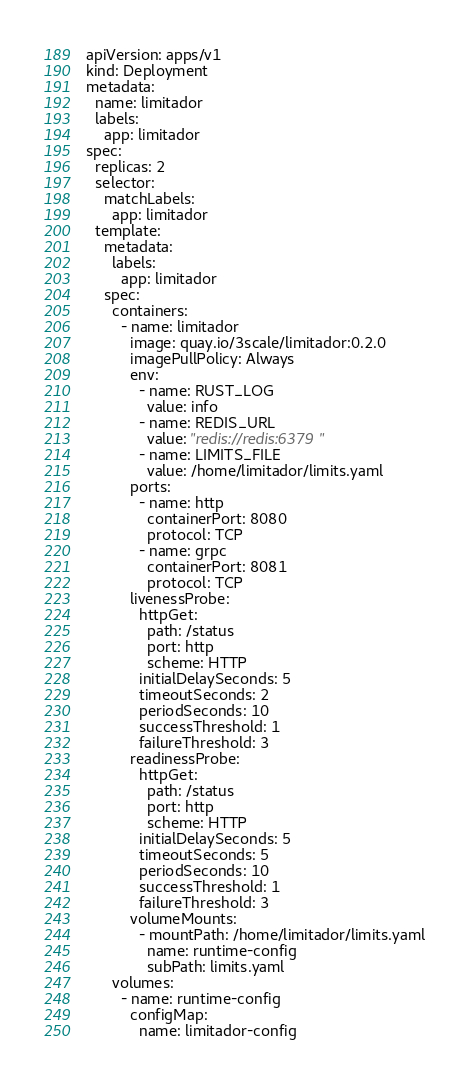<code> <loc_0><loc_0><loc_500><loc_500><_YAML_>apiVersion: apps/v1
kind: Deployment
metadata:
  name: limitador
  labels:
    app: limitador
spec:
  replicas: 2
  selector:
    matchLabels:
      app: limitador
  template:
    metadata:
      labels:
        app: limitador
    spec:
      containers:
        - name: limitador
          image: quay.io/3scale/limitador:0.2.0
          imagePullPolicy: Always
          env:
            - name: RUST_LOG
              value: info
            - name: REDIS_URL
              value: "redis://redis:6379"
            - name: LIMITS_FILE
              value: /home/limitador/limits.yaml
          ports:
            - name: http
              containerPort: 8080
              protocol: TCP
            - name: grpc
              containerPort: 8081
              protocol: TCP
          livenessProbe:
            httpGet:
              path: /status
              port: http
              scheme: HTTP
            initialDelaySeconds: 5
            timeoutSeconds: 2
            periodSeconds: 10
            successThreshold: 1
            failureThreshold: 3
          readinessProbe:
            httpGet:
              path: /status
              port: http
              scheme: HTTP
            initialDelaySeconds: 5
            timeoutSeconds: 5
            periodSeconds: 10
            successThreshold: 1
            failureThreshold: 3
          volumeMounts:
            - mountPath: /home/limitador/limits.yaml
              name: runtime-config
              subPath: limits.yaml
      volumes:
        - name: runtime-config
          configMap:
            name: limitador-config</code> 